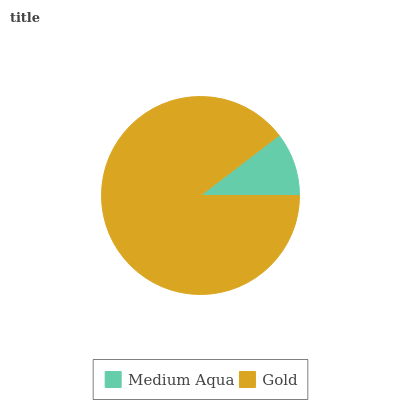Is Medium Aqua the minimum?
Answer yes or no. Yes. Is Gold the maximum?
Answer yes or no. Yes. Is Gold the minimum?
Answer yes or no. No. Is Gold greater than Medium Aqua?
Answer yes or no. Yes. Is Medium Aqua less than Gold?
Answer yes or no. Yes. Is Medium Aqua greater than Gold?
Answer yes or no. No. Is Gold less than Medium Aqua?
Answer yes or no. No. Is Gold the high median?
Answer yes or no. Yes. Is Medium Aqua the low median?
Answer yes or no. Yes. Is Medium Aqua the high median?
Answer yes or no. No. Is Gold the low median?
Answer yes or no. No. 